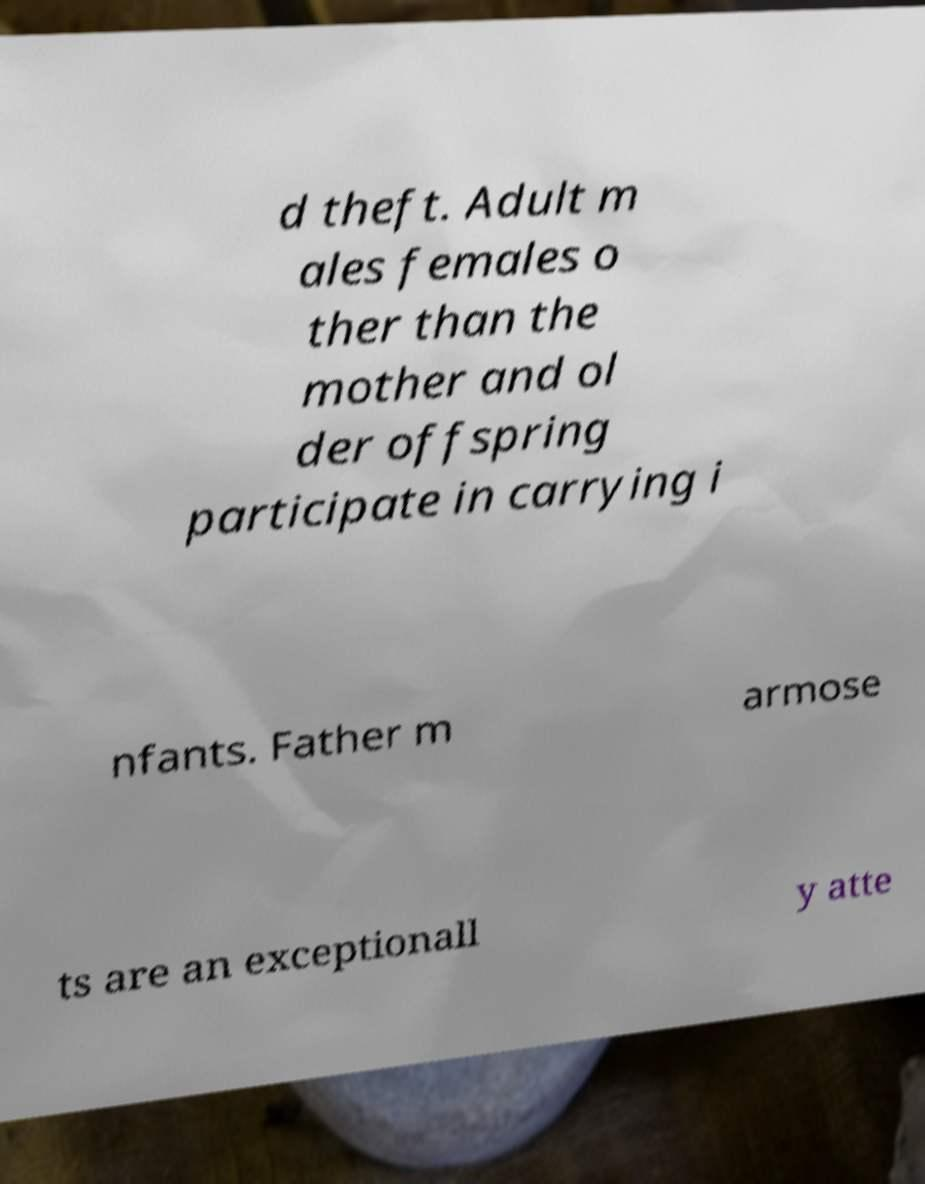I need the written content from this picture converted into text. Can you do that? d theft. Adult m ales females o ther than the mother and ol der offspring participate in carrying i nfants. Father m armose ts are an exceptionall y atte 